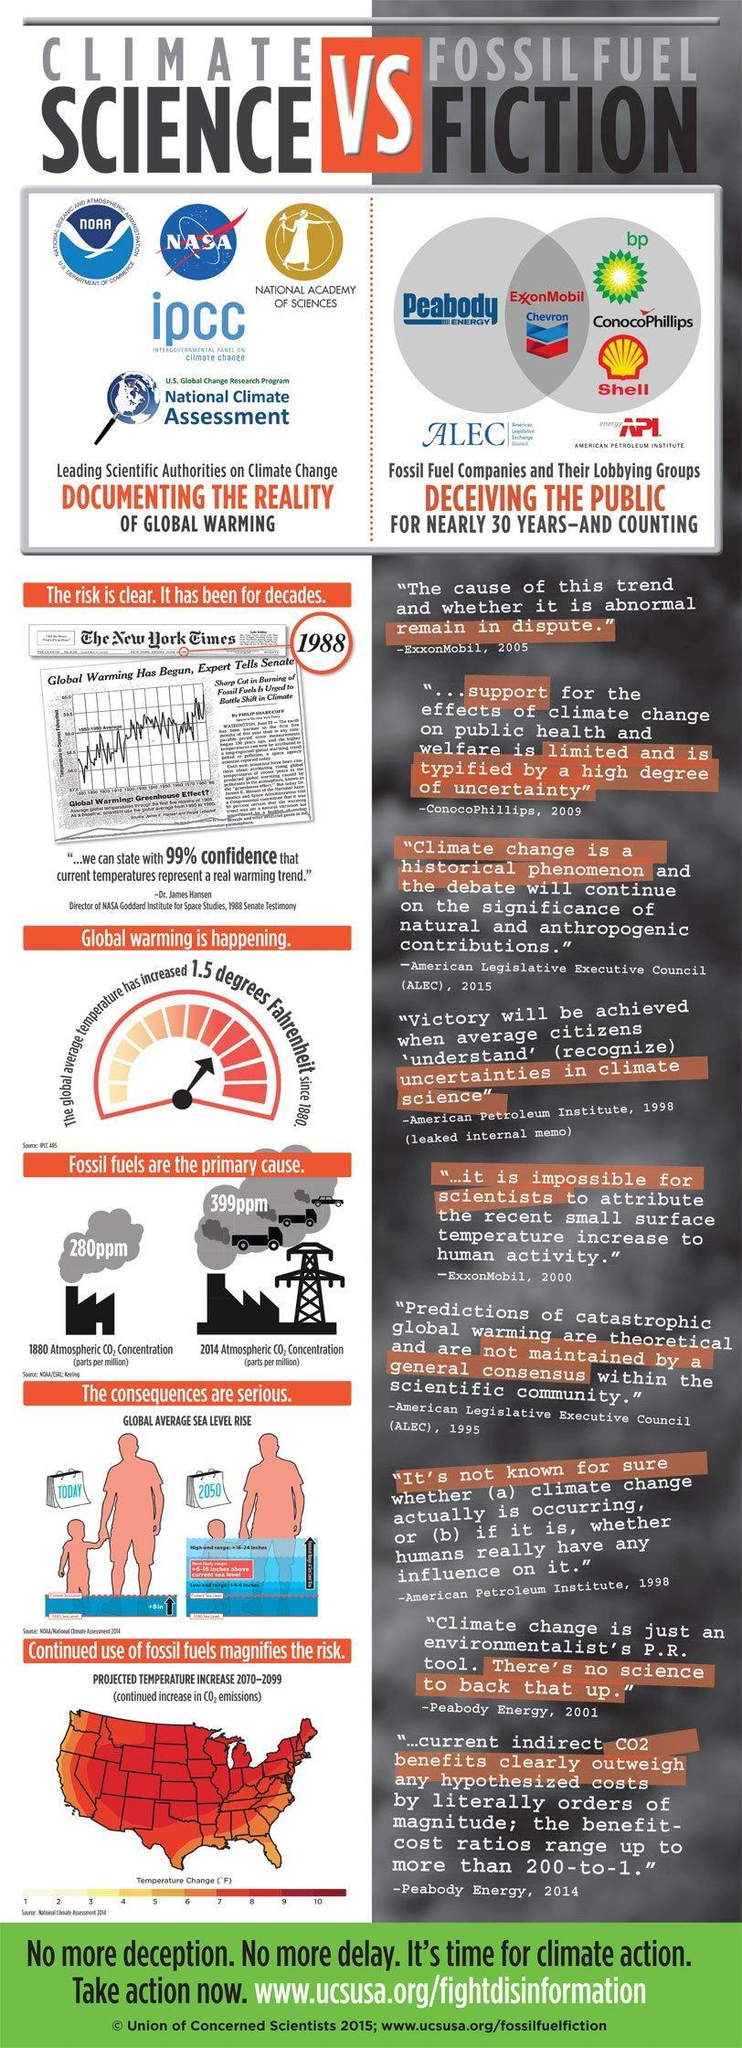What was the 1880 atmospheric Carbon dioxide concentration (in parts per million)?
Answer the question with a short phrase. 280ppm Who gave testimony in senate in 1988 about global warming? Dr. James Hansen Who are deceiving the public about global warming? fossil fuel companies and their lobbying groups What was the atmospheric concentration of carbon dioxide (in parts per million) for the year 2014? 399ppm For which year does the image represent very high rise in global sea level? 2050 